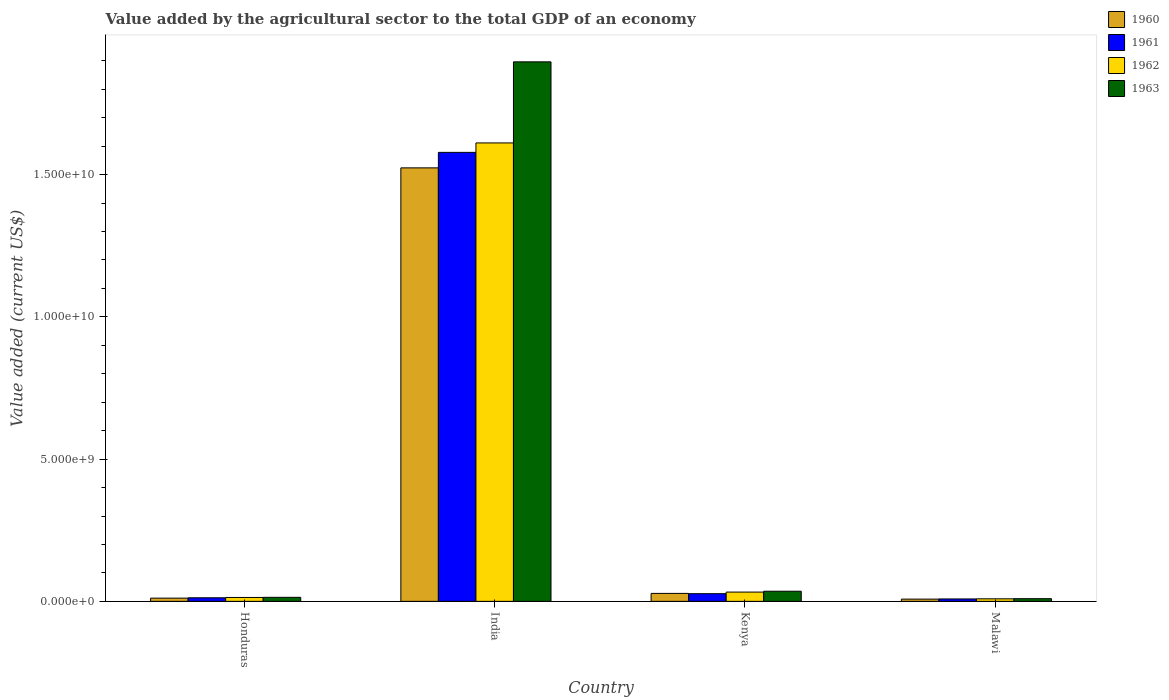How many different coloured bars are there?
Make the answer very short. 4. How many groups of bars are there?
Offer a terse response. 4. Are the number of bars on each tick of the X-axis equal?
Make the answer very short. Yes. What is the label of the 1st group of bars from the left?
Give a very brief answer. Honduras. In how many cases, is the number of bars for a given country not equal to the number of legend labels?
Keep it short and to the point. 0. What is the value added by the agricultural sector to the total GDP in 1963 in Kenya?
Ensure brevity in your answer.  3.56e+08. Across all countries, what is the maximum value added by the agricultural sector to the total GDP in 1960?
Your response must be concise. 1.52e+1. Across all countries, what is the minimum value added by the agricultural sector to the total GDP in 1961?
Make the answer very short. 8.48e+07. In which country was the value added by the agricultural sector to the total GDP in 1961 maximum?
Provide a short and direct response. India. In which country was the value added by the agricultural sector to the total GDP in 1962 minimum?
Offer a terse response. Malawi. What is the total value added by the agricultural sector to the total GDP in 1962 in the graph?
Your response must be concise. 1.67e+1. What is the difference between the value added by the agricultural sector to the total GDP in 1963 in India and that in Kenya?
Your answer should be very brief. 1.86e+1. What is the difference between the value added by the agricultural sector to the total GDP in 1960 in India and the value added by the agricultural sector to the total GDP in 1962 in Honduras?
Provide a succinct answer. 1.51e+1. What is the average value added by the agricultural sector to the total GDP in 1963 per country?
Your answer should be very brief. 4.89e+09. What is the difference between the value added by the agricultural sector to the total GDP of/in 1960 and value added by the agricultural sector to the total GDP of/in 1961 in Honduras?
Your response must be concise. -1.21e+07. In how many countries, is the value added by the agricultural sector to the total GDP in 1963 greater than 10000000000 US$?
Make the answer very short. 1. What is the ratio of the value added by the agricultural sector to the total GDP in 1961 in India to that in Kenya?
Offer a terse response. 58.42. What is the difference between the highest and the second highest value added by the agricultural sector to the total GDP in 1960?
Make the answer very short. -1.66e+08. What is the difference between the highest and the lowest value added by the agricultural sector to the total GDP in 1962?
Ensure brevity in your answer.  1.60e+1. In how many countries, is the value added by the agricultural sector to the total GDP in 1962 greater than the average value added by the agricultural sector to the total GDP in 1962 taken over all countries?
Provide a short and direct response. 1. Is it the case that in every country, the sum of the value added by the agricultural sector to the total GDP in 1963 and value added by the agricultural sector to the total GDP in 1962 is greater than the sum of value added by the agricultural sector to the total GDP in 1960 and value added by the agricultural sector to the total GDP in 1961?
Provide a short and direct response. No. What does the 4th bar from the left in Malawi represents?
Provide a succinct answer. 1963. Is it the case that in every country, the sum of the value added by the agricultural sector to the total GDP in 1963 and value added by the agricultural sector to the total GDP in 1960 is greater than the value added by the agricultural sector to the total GDP in 1961?
Your answer should be compact. Yes. Are all the bars in the graph horizontal?
Offer a very short reply. No. What is the difference between two consecutive major ticks on the Y-axis?
Keep it short and to the point. 5.00e+09. Are the values on the major ticks of Y-axis written in scientific E-notation?
Make the answer very short. Yes. Does the graph contain any zero values?
Keep it short and to the point. No. Does the graph contain grids?
Provide a succinct answer. No. Where does the legend appear in the graph?
Make the answer very short. Top right. How many legend labels are there?
Provide a short and direct response. 4. How are the legend labels stacked?
Your response must be concise. Vertical. What is the title of the graph?
Offer a terse response. Value added by the agricultural sector to the total GDP of an economy. What is the label or title of the Y-axis?
Provide a succinct answer. Value added (current US$). What is the Value added (current US$) in 1960 in Honduras?
Your answer should be very brief. 1.14e+08. What is the Value added (current US$) in 1961 in Honduras?
Ensure brevity in your answer.  1.26e+08. What is the Value added (current US$) of 1962 in Honduras?
Your answer should be very brief. 1.37e+08. What is the Value added (current US$) of 1963 in Honduras?
Provide a succinct answer. 1.41e+08. What is the Value added (current US$) of 1960 in India?
Give a very brief answer. 1.52e+1. What is the Value added (current US$) of 1961 in India?
Offer a terse response. 1.58e+1. What is the Value added (current US$) in 1962 in India?
Your response must be concise. 1.61e+1. What is the Value added (current US$) in 1963 in India?
Give a very brief answer. 1.90e+1. What is the Value added (current US$) in 1960 in Kenya?
Provide a succinct answer. 2.80e+08. What is the Value added (current US$) of 1961 in Kenya?
Your response must be concise. 2.70e+08. What is the Value added (current US$) of 1962 in Kenya?
Your answer should be compact. 3.26e+08. What is the Value added (current US$) of 1963 in Kenya?
Keep it short and to the point. 3.56e+08. What is the Value added (current US$) in 1960 in Malawi?
Your answer should be compact. 7.88e+07. What is the Value added (current US$) in 1961 in Malawi?
Your answer should be very brief. 8.48e+07. What is the Value added (current US$) of 1962 in Malawi?
Provide a succinct answer. 8.90e+07. What is the Value added (current US$) of 1963 in Malawi?
Your response must be concise. 9.39e+07. Across all countries, what is the maximum Value added (current US$) in 1960?
Ensure brevity in your answer.  1.52e+1. Across all countries, what is the maximum Value added (current US$) in 1961?
Keep it short and to the point. 1.58e+1. Across all countries, what is the maximum Value added (current US$) in 1962?
Provide a succinct answer. 1.61e+1. Across all countries, what is the maximum Value added (current US$) of 1963?
Provide a short and direct response. 1.90e+1. Across all countries, what is the minimum Value added (current US$) of 1960?
Ensure brevity in your answer.  7.88e+07. Across all countries, what is the minimum Value added (current US$) in 1961?
Provide a succinct answer. 8.48e+07. Across all countries, what is the minimum Value added (current US$) in 1962?
Keep it short and to the point. 8.90e+07. Across all countries, what is the minimum Value added (current US$) of 1963?
Provide a short and direct response. 9.39e+07. What is the total Value added (current US$) in 1960 in the graph?
Your answer should be very brief. 1.57e+1. What is the total Value added (current US$) of 1961 in the graph?
Ensure brevity in your answer.  1.63e+1. What is the total Value added (current US$) of 1962 in the graph?
Keep it short and to the point. 1.67e+1. What is the total Value added (current US$) of 1963 in the graph?
Make the answer very short. 1.96e+1. What is the difference between the Value added (current US$) of 1960 in Honduras and that in India?
Make the answer very short. -1.51e+1. What is the difference between the Value added (current US$) in 1961 in Honduras and that in India?
Offer a very short reply. -1.57e+1. What is the difference between the Value added (current US$) of 1962 in Honduras and that in India?
Offer a very short reply. -1.60e+1. What is the difference between the Value added (current US$) of 1963 in Honduras and that in India?
Your answer should be very brief. -1.88e+1. What is the difference between the Value added (current US$) of 1960 in Honduras and that in Kenya?
Offer a terse response. -1.66e+08. What is the difference between the Value added (current US$) in 1961 in Honduras and that in Kenya?
Provide a succinct answer. -1.45e+08. What is the difference between the Value added (current US$) in 1962 in Honduras and that in Kenya?
Make the answer very short. -1.89e+08. What is the difference between the Value added (current US$) of 1963 in Honduras and that in Kenya?
Provide a short and direct response. -2.15e+08. What is the difference between the Value added (current US$) of 1960 in Honduras and that in Malawi?
Your response must be concise. 3.47e+07. What is the difference between the Value added (current US$) of 1961 in Honduras and that in Malawi?
Your answer should be very brief. 4.08e+07. What is the difference between the Value added (current US$) of 1962 in Honduras and that in Malawi?
Your answer should be compact. 4.82e+07. What is the difference between the Value added (current US$) in 1963 in Honduras and that in Malawi?
Provide a succinct answer. 4.72e+07. What is the difference between the Value added (current US$) of 1960 in India and that in Kenya?
Give a very brief answer. 1.50e+1. What is the difference between the Value added (current US$) of 1961 in India and that in Kenya?
Your answer should be compact. 1.55e+1. What is the difference between the Value added (current US$) in 1962 in India and that in Kenya?
Offer a very short reply. 1.58e+1. What is the difference between the Value added (current US$) in 1963 in India and that in Kenya?
Provide a succinct answer. 1.86e+1. What is the difference between the Value added (current US$) in 1960 in India and that in Malawi?
Offer a terse response. 1.52e+1. What is the difference between the Value added (current US$) of 1961 in India and that in Malawi?
Your response must be concise. 1.57e+1. What is the difference between the Value added (current US$) in 1962 in India and that in Malawi?
Make the answer very short. 1.60e+1. What is the difference between the Value added (current US$) in 1963 in India and that in Malawi?
Your answer should be very brief. 1.89e+1. What is the difference between the Value added (current US$) of 1960 in Kenya and that in Malawi?
Your answer should be compact. 2.01e+08. What is the difference between the Value added (current US$) of 1961 in Kenya and that in Malawi?
Offer a terse response. 1.85e+08. What is the difference between the Value added (current US$) of 1962 in Kenya and that in Malawi?
Ensure brevity in your answer.  2.37e+08. What is the difference between the Value added (current US$) in 1963 in Kenya and that in Malawi?
Offer a terse response. 2.62e+08. What is the difference between the Value added (current US$) of 1960 in Honduras and the Value added (current US$) of 1961 in India?
Provide a short and direct response. -1.57e+1. What is the difference between the Value added (current US$) of 1960 in Honduras and the Value added (current US$) of 1962 in India?
Provide a short and direct response. -1.60e+1. What is the difference between the Value added (current US$) in 1960 in Honduras and the Value added (current US$) in 1963 in India?
Provide a short and direct response. -1.89e+1. What is the difference between the Value added (current US$) of 1961 in Honduras and the Value added (current US$) of 1962 in India?
Provide a succinct answer. -1.60e+1. What is the difference between the Value added (current US$) in 1961 in Honduras and the Value added (current US$) in 1963 in India?
Provide a succinct answer. -1.88e+1. What is the difference between the Value added (current US$) of 1962 in Honduras and the Value added (current US$) of 1963 in India?
Offer a terse response. -1.88e+1. What is the difference between the Value added (current US$) of 1960 in Honduras and the Value added (current US$) of 1961 in Kenya?
Offer a very short reply. -1.57e+08. What is the difference between the Value added (current US$) of 1960 in Honduras and the Value added (current US$) of 1962 in Kenya?
Your response must be concise. -2.13e+08. What is the difference between the Value added (current US$) in 1960 in Honduras and the Value added (current US$) in 1963 in Kenya?
Offer a very short reply. -2.43e+08. What is the difference between the Value added (current US$) of 1961 in Honduras and the Value added (current US$) of 1962 in Kenya?
Give a very brief answer. -2.01e+08. What is the difference between the Value added (current US$) of 1961 in Honduras and the Value added (current US$) of 1963 in Kenya?
Offer a very short reply. -2.31e+08. What is the difference between the Value added (current US$) in 1962 in Honduras and the Value added (current US$) in 1963 in Kenya?
Make the answer very short. -2.19e+08. What is the difference between the Value added (current US$) in 1960 in Honduras and the Value added (current US$) in 1961 in Malawi?
Your response must be concise. 2.87e+07. What is the difference between the Value added (current US$) in 1960 in Honduras and the Value added (current US$) in 1962 in Malawi?
Provide a short and direct response. 2.45e+07. What is the difference between the Value added (current US$) of 1960 in Honduras and the Value added (current US$) of 1963 in Malawi?
Your response must be concise. 1.96e+07. What is the difference between the Value added (current US$) of 1961 in Honduras and the Value added (current US$) of 1962 in Malawi?
Make the answer very short. 3.66e+07. What is the difference between the Value added (current US$) of 1961 in Honduras and the Value added (current US$) of 1963 in Malawi?
Your answer should be compact. 3.17e+07. What is the difference between the Value added (current US$) in 1962 in Honduras and the Value added (current US$) in 1963 in Malawi?
Offer a terse response. 4.33e+07. What is the difference between the Value added (current US$) in 1960 in India and the Value added (current US$) in 1961 in Kenya?
Offer a very short reply. 1.50e+1. What is the difference between the Value added (current US$) in 1960 in India and the Value added (current US$) in 1962 in Kenya?
Your answer should be very brief. 1.49e+1. What is the difference between the Value added (current US$) of 1960 in India and the Value added (current US$) of 1963 in Kenya?
Provide a short and direct response. 1.49e+1. What is the difference between the Value added (current US$) in 1961 in India and the Value added (current US$) in 1962 in Kenya?
Offer a terse response. 1.55e+1. What is the difference between the Value added (current US$) in 1961 in India and the Value added (current US$) in 1963 in Kenya?
Offer a terse response. 1.54e+1. What is the difference between the Value added (current US$) in 1962 in India and the Value added (current US$) in 1963 in Kenya?
Ensure brevity in your answer.  1.58e+1. What is the difference between the Value added (current US$) of 1960 in India and the Value added (current US$) of 1961 in Malawi?
Give a very brief answer. 1.52e+1. What is the difference between the Value added (current US$) in 1960 in India and the Value added (current US$) in 1962 in Malawi?
Your response must be concise. 1.51e+1. What is the difference between the Value added (current US$) in 1960 in India and the Value added (current US$) in 1963 in Malawi?
Provide a short and direct response. 1.51e+1. What is the difference between the Value added (current US$) of 1961 in India and the Value added (current US$) of 1962 in Malawi?
Provide a succinct answer. 1.57e+1. What is the difference between the Value added (current US$) in 1961 in India and the Value added (current US$) in 1963 in Malawi?
Your answer should be very brief. 1.57e+1. What is the difference between the Value added (current US$) in 1962 in India and the Value added (current US$) in 1963 in Malawi?
Your answer should be compact. 1.60e+1. What is the difference between the Value added (current US$) of 1960 in Kenya and the Value added (current US$) of 1961 in Malawi?
Offer a terse response. 1.95e+08. What is the difference between the Value added (current US$) of 1960 in Kenya and the Value added (current US$) of 1962 in Malawi?
Give a very brief answer. 1.91e+08. What is the difference between the Value added (current US$) of 1960 in Kenya and the Value added (current US$) of 1963 in Malawi?
Make the answer very short. 1.86e+08. What is the difference between the Value added (current US$) in 1961 in Kenya and the Value added (current US$) in 1962 in Malawi?
Your answer should be very brief. 1.81e+08. What is the difference between the Value added (current US$) of 1961 in Kenya and the Value added (current US$) of 1963 in Malawi?
Your answer should be compact. 1.76e+08. What is the difference between the Value added (current US$) in 1962 in Kenya and the Value added (current US$) in 1963 in Malawi?
Keep it short and to the point. 2.32e+08. What is the average Value added (current US$) of 1960 per country?
Provide a succinct answer. 3.93e+09. What is the average Value added (current US$) of 1961 per country?
Make the answer very short. 4.07e+09. What is the average Value added (current US$) of 1962 per country?
Ensure brevity in your answer.  4.17e+09. What is the average Value added (current US$) in 1963 per country?
Provide a succinct answer. 4.89e+09. What is the difference between the Value added (current US$) in 1960 and Value added (current US$) in 1961 in Honduras?
Give a very brief answer. -1.21e+07. What is the difference between the Value added (current US$) in 1960 and Value added (current US$) in 1962 in Honduras?
Ensure brevity in your answer.  -2.38e+07. What is the difference between the Value added (current US$) of 1960 and Value added (current US$) of 1963 in Honduras?
Your answer should be compact. -2.76e+07. What is the difference between the Value added (current US$) in 1961 and Value added (current US$) in 1962 in Honduras?
Keep it short and to the point. -1.16e+07. What is the difference between the Value added (current US$) of 1961 and Value added (current US$) of 1963 in Honduras?
Keep it short and to the point. -1.56e+07. What is the difference between the Value added (current US$) in 1962 and Value added (current US$) in 1963 in Honduras?
Your response must be concise. -3.90e+06. What is the difference between the Value added (current US$) in 1960 and Value added (current US$) in 1961 in India?
Offer a terse response. -5.45e+08. What is the difference between the Value added (current US$) of 1960 and Value added (current US$) of 1962 in India?
Your response must be concise. -8.76e+08. What is the difference between the Value added (current US$) of 1960 and Value added (current US$) of 1963 in India?
Your answer should be very brief. -3.73e+09. What is the difference between the Value added (current US$) in 1961 and Value added (current US$) in 1962 in India?
Offer a very short reply. -3.32e+08. What is the difference between the Value added (current US$) of 1961 and Value added (current US$) of 1963 in India?
Your answer should be very brief. -3.18e+09. What is the difference between the Value added (current US$) in 1962 and Value added (current US$) in 1963 in India?
Make the answer very short. -2.85e+09. What is the difference between the Value added (current US$) of 1960 and Value added (current US$) of 1961 in Kenya?
Your response must be concise. 9.51e+06. What is the difference between the Value added (current US$) in 1960 and Value added (current US$) in 1962 in Kenya?
Provide a succinct answer. -4.65e+07. What is the difference between the Value added (current US$) of 1960 and Value added (current US$) of 1963 in Kenya?
Your answer should be compact. -7.66e+07. What is the difference between the Value added (current US$) of 1961 and Value added (current US$) of 1962 in Kenya?
Your answer should be very brief. -5.60e+07. What is the difference between the Value added (current US$) of 1961 and Value added (current US$) of 1963 in Kenya?
Make the answer very short. -8.61e+07. What is the difference between the Value added (current US$) in 1962 and Value added (current US$) in 1963 in Kenya?
Provide a succinct answer. -3.01e+07. What is the difference between the Value added (current US$) of 1960 and Value added (current US$) of 1961 in Malawi?
Your answer should be very brief. -6.02e+06. What is the difference between the Value added (current US$) in 1960 and Value added (current US$) in 1962 in Malawi?
Ensure brevity in your answer.  -1.02e+07. What is the difference between the Value added (current US$) of 1960 and Value added (current US$) of 1963 in Malawi?
Your answer should be very brief. -1.51e+07. What is the difference between the Value added (current US$) of 1961 and Value added (current US$) of 1962 in Malawi?
Provide a short and direct response. -4.20e+06. What is the difference between the Value added (current US$) of 1961 and Value added (current US$) of 1963 in Malawi?
Keep it short and to the point. -9.10e+06. What is the difference between the Value added (current US$) of 1962 and Value added (current US$) of 1963 in Malawi?
Provide a succinct answer. -4.90e+06. What is the ratio of the Value added (current US$) of 1960 in Honduras to that in India?
Your response must be concise. 0.01. What is the ratio of the Value added (current US$) in 1961 in Honduras to that in India?
Offer a terse response. 0.01. What is the ratio of the Value added (current US$) in 1962 in Honduras to that in India?
Give a very brief answer. 0.01. What is the ratio of the Value added (current US$) of 1963 in Honduras to that in India?
Provide a short and direct response. 0.01. What is the ratio of the Value added (current US$) of 1960 in Honduras to that in Kenya?
Give a very brief answer. 0.41. What is the ratio of the Value added (current US$) in 1961 in Honduras to that in Kenya?
Offer a very short reply. 0.46. What is the ratio of the Value added (current US$) of 1962 in Honduras to that in Kenya?
Make the answer very short. 0.42. What is the ratio of the Value added (current US$) of 1963 in Honduras to that in Kenya?
Ensure brevity in your answer.  0.4. What is the ratio of the Value added (current US$) in 1960 in Honduras to that in Malawi?
Your answer should be compact. 1.44. What is the ratio of the Value added (current US$) of 1961 in Honduras to that in Malawi?
Make the answer very short. 1.48. What is the ratio of the Value added (current US$) of 1962 in Honduras to that in Malawi?
Give a very brief answer. 1.54. What is the ratio of the Value added (current US$) of 1963 in Honduras to that in Malawi?
Provide a succinct answer. 1.5. What is the ratio of the Value added (current US$) of 1960 in India to that in Kenya?
Ensure brevity in your answer.  54.48. What is the ratio of the Value added (current US$) in 1961 in India to that in Kenya?
Offer a very short reply. 58.42. What is the ratio of the Value added (current US$) in 1962 in India to that in Kenya?
Make the answer very short. 49.4. What is the ratio of the Value added (current US$) of 1963 in India to that in Kenya?
Your response must be concise. 53.23. What is the ratio of the Value added (current US$) of 1960 in India to that in Malawi?
Offer a very short reply. 193.33. What is the ratio of the Value added (current US$) of 1961 in India to that in Malawi?
Your answer should be compact. 186.04. What is the ratio of the Value added (current US$) of 1962 in India to that in Malawi?
Your response must be concise. 180.99. What is the ratio of the Value added (current US$) of 1963 in India to that in Malawi?
Offer a terse response. 201.89. What is the ratio of the Value added (current US$) in 1960 in Kenya to that in Malawi?
Your answer should be compact. 3.55. What is the ratio of the Value added (current US$) of 1961 in Kenya to that in Malawi?
Your answer should be compact. 3.18. What is the ratio of the Value added (current US$) of 1962 in Kenya to that in Malawi?
Provide a short and direct response. 3.66. What is the ratio of the Value added (current US$) of 1963 in Kenya to that in Malawi?
Provide a short and direct response. 3.79. What is the difference between the highest and the second highest Value added (current US$) in 1960?
Keep it short and to the point. 1.50e+1. What is the difference between the highest and the second highest Value added (current US$) in 1961?
Your answer should be very brief. 1.55e+1. What is the difference between the highest and the second highest Value added (current US$) in 1962?
Keep it short and to the point. 1.58e+1. What is the difference between the highest and the second highest Value added (current US$) in 1963?
Offer a terse response. 1.86e+1. What is the difference between the highest and the lowest Value added (current US$) in 1960?
Give a very brief answer. 1.52e+1. What is the difference between the highest and the lowest Value added (current US$) in 1961?
Your answer should be compact. 1.57e+1. What is the difference between the highest and the lowest Value added (current US$) in 1962?
Your answer should be compact. 1.60e+1. What is the difference between the highest and the lowest Value added (current US$) of 1963?
Offer a terse response. 1.89e+1. 